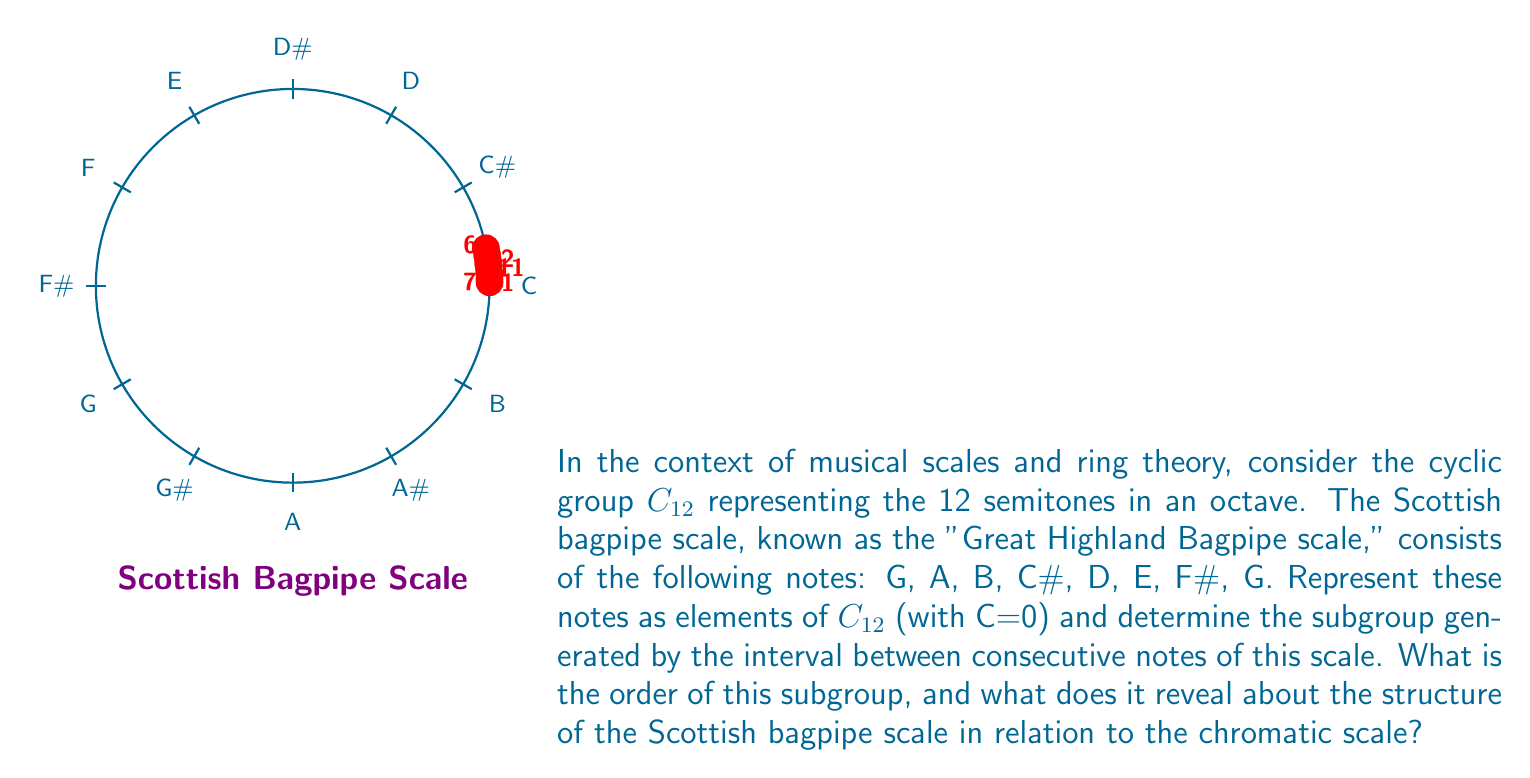Could you help me with this problem? Let's approach this step-by-step:

1) First, we need to represent the Scottish bagpipe scale in $C_{12}$:
   G = 7, A = 9, B = 11, C# = 1, D = 2, E = 4, F# = 6, G = 7

2) Now, let's calculate the intervals between consecutive notes:
   7 to 9: 2
   9 to 11: 2
   11 to 1: 2
   1 to 2: 1
   2 to 4: 2
   4 to 6: 2
   6 to 7: 1

3) We see that the intervals are either 1 or 2 semitones. Let's consider the subgroup generated by these intervals, which is $\langle 1, 2 \rangle$ in $C_{12}$.

4) To find the order of this subgroup, we need to determine the smallest positive integer $n$ such that $n \cdot 1 \equiv 0 \pmod{12}$ and $n \cdot 2 \equiv 0 \pmod{12}$.

5) Clearly, $12 \cdot 1 \equiv 0 \pmod{12}$, and $6 \cdot 2 \equiv 0 \pmod{12}$. The least common multiple of 12 and 6 is 12.

6) Therefore, the subgroup $\langle 1, 2 \rangle$ has order 12, which means it generates the entire group $C_{12}$.

7) This reveals that the Scottish bagpipe scale, despite using only 8 notes, generates intervals that can produce all 12 semitones of the chromatic scale.

8) In ring theory terms, the ideal generated by the intervals of the Scottish bagpipe scale is the entire ring $\mathbb{Z}_{12}$, showing that this scale has a rich harmonic structure capable of accessing all notes in the 12-tone system.
Answer: The subgroup has order 12, revealing that the Scottish bagpipe scale generates the full chromatic scale. 